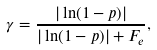Convert formula to latex. <formula><loc_0><loc_0><loc_500><loc_500>\gamma = \frac { | \ln ( 1 - p ) | } { | \ln ( 1 - p ) | + F _ { e } } ,</formula> 